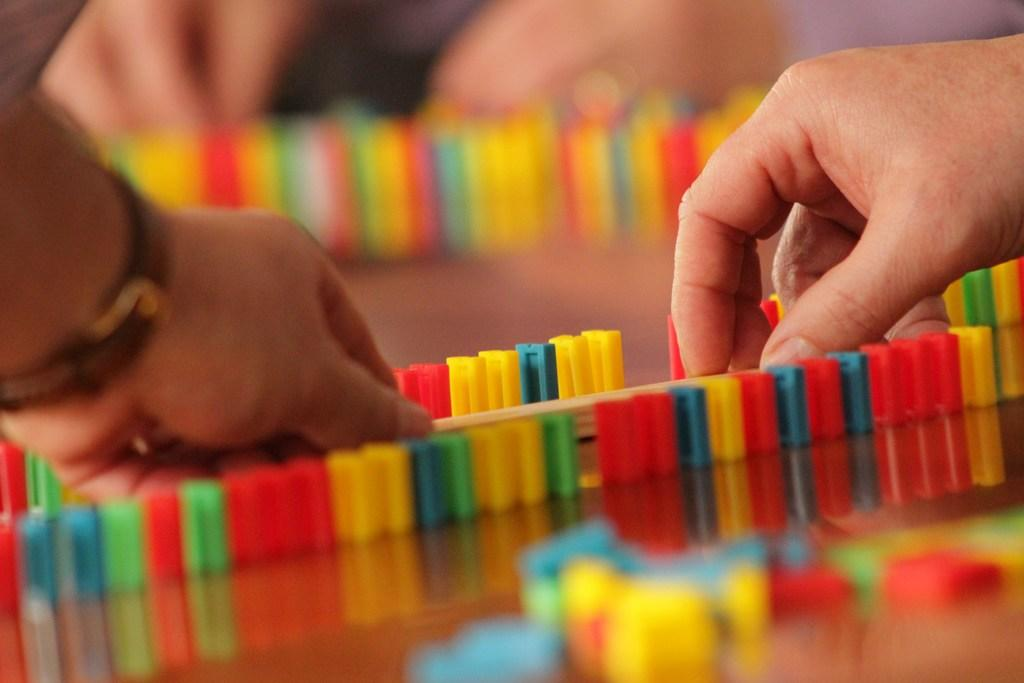What body part is visible in the image? There are a person's hands in the image. What can be said about the colors of the objects in the image? The objects in the image are in multi color. What type of picture is being taken in the image? There is no indication of a picture being taken in the image; it only shows a person's hands and multi-colored objects. 